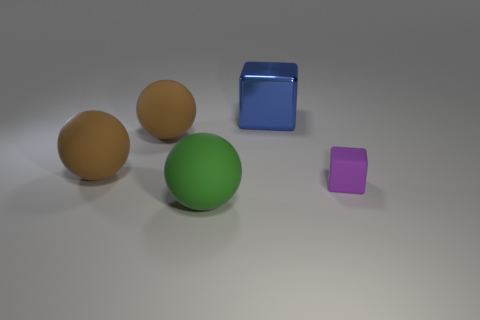Add 3 big blue things. How many objects exist? 8 Subtract all cyan cubes. How many brown spheres are left? 2 Subtract all large brown rubber spheres. How many spheres are left? 1 Subtract 1 spheres. How many spheres are left? 2 Subtract all balls. How many objects are left? 2 Subtract all tiny gray things. Subtract all large blue cubes. How many objects are left? 4 Add 3 brown rubber balls. How many brown rubber balls are left? 5 Add 1 large things. How many large things exist? 5 Subtract 0 blue cylinders. How many objects are left? 5 Subtract all brown cubes. Subtract all red spheres. How many cubes are left? 2 